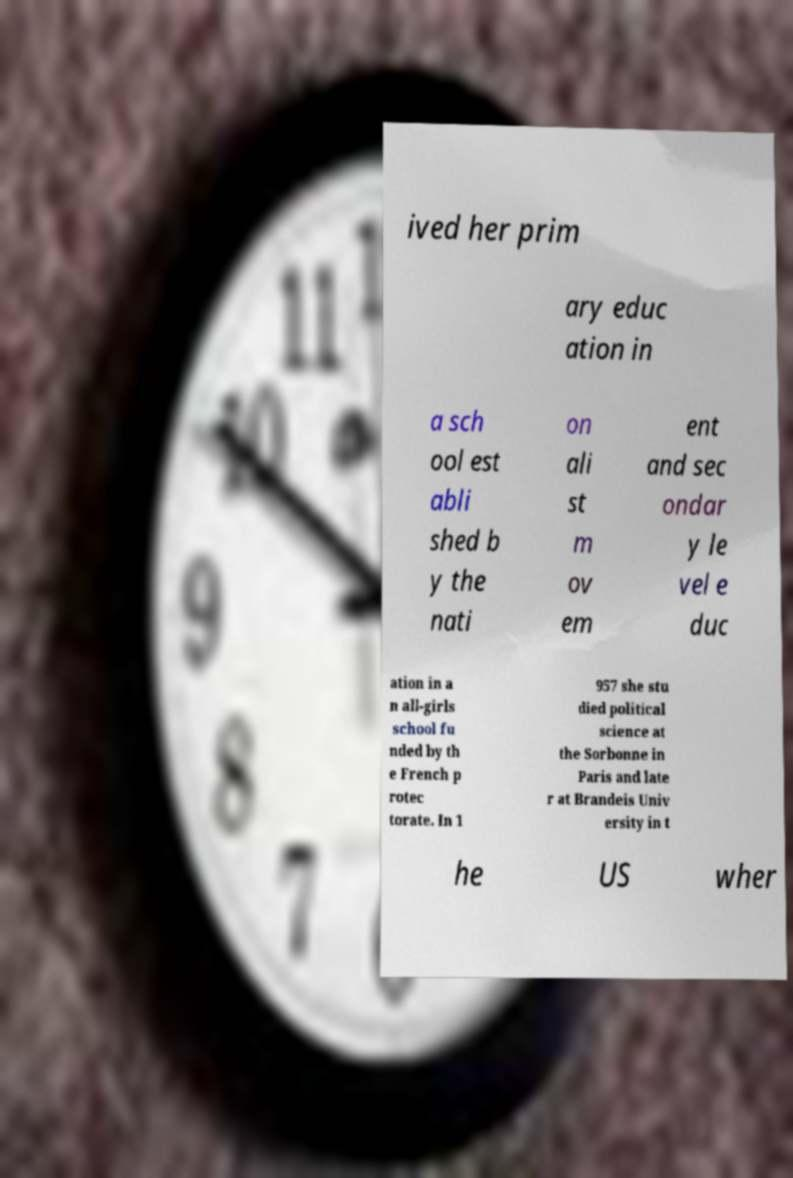Can you read and provide the text displayed in the image?This photo seems to have some interesting text. Can you extract and type it out for me? ived her prim ary educ ation in a sch ool est abli shed b y the nati on ali st m ov em ent and sec ondar y le vel e duc ation in a n all-girls school fu nded by th e French p rotec torate. In 1 957 she stu died political science at the Sorbonne in Paris and late r at Brandeis Univ ersity in t he US wher 